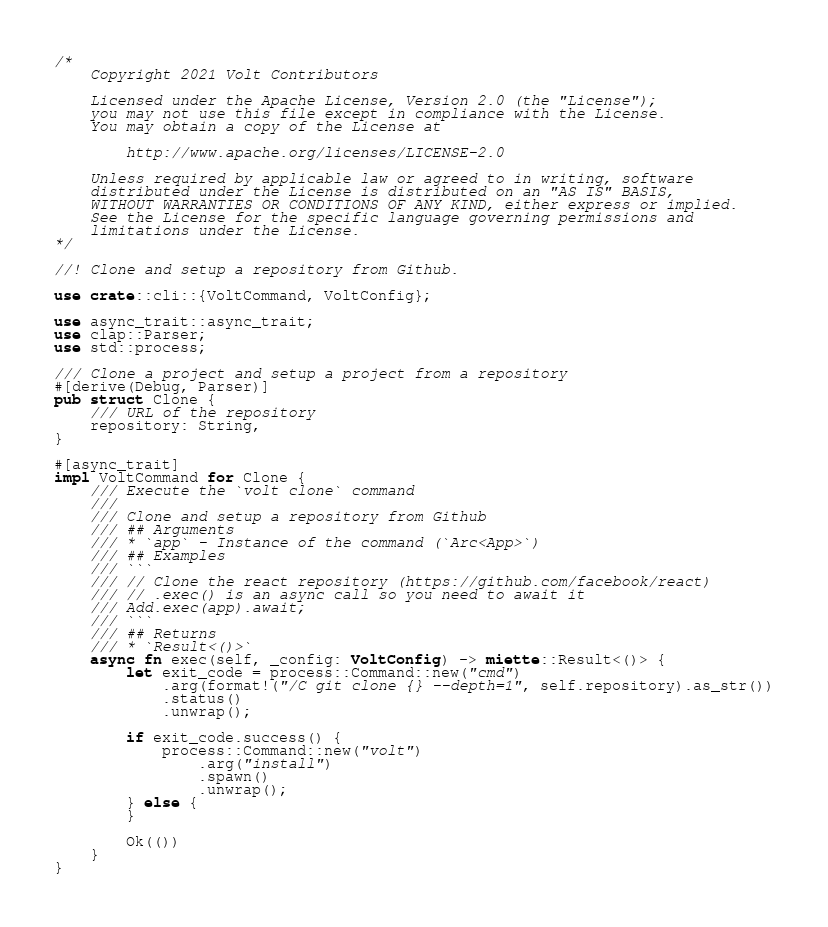Convert code to text. <code><loc_0><loc_0><loc_500><loc_500><_Rust_>/*
    Copyright 2021 Volt Contributors

    Licensed under the Apache License, Version 2.0 (the "License");
    you may not use this file except in compliance with the License.
    You may obtain a copy of the License at

        http://www.apache.org/licenses/LICENSE-2.0

    Unless required by applicable law or agreed to in writing, software
    distributed under the License is distributed on an "AS IS" BASIS,
    WITHOUT WARRANTIES OR CONDITIONS OF ANY KIND, either express or implied.
    See the License for the specific language governing permissions and
    limitations under the License.
*/

//! Clone and setup a repository from Github.

use crate::cli::{VoltCommand, VoltConfig};

use async_trait::async_trait;
use clap::Parser;
use std::process;

/// Clone a project and setup a project from a repository
#[derive(Debug, Parser)]
pub struct Clone {
    /// URL of the repository
    repository: String,
}

#[async_trait]
impl VoltCommand for Clone {
    /// Execute the `volt clone` command
    ///
    /// Clone and setup a repository from Github
    /// ## Arguments
    /// * `app` - Instance of the command (`Arc<App>`)
    /// ## Examples
    /// ```
    /// // Clone the react repository (https://github.com/facebook/react)
    /// // .exec() is an async call so you need to await it
    /// Add.exec(app).await;
    /// ```
    /// ## Returns
    /// * `Result<()>`
    async fn exec(self, _config: VoltConfig) -> miette::Result<()> {
        let exit_code = process::Command::new("cmd")
            .arg(format!("/C git clone {} --depth=1", self.repository).as_str())
            .status()
            .unwrap();

        if exit_code.success() {
            process::Command::new("volt")
                .arg("install")
                .spawn()
                .unwrap();
        } else {
        }

        Ok(())
    }
}
</code> 